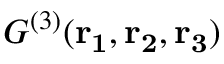<formula> <loc_0><loc_0><loc_500><loc_500>{ G ^ { ( 3 ) } } ( r _ { 1 } , r _ { 2 } , r _ { 3 } )</formula> 